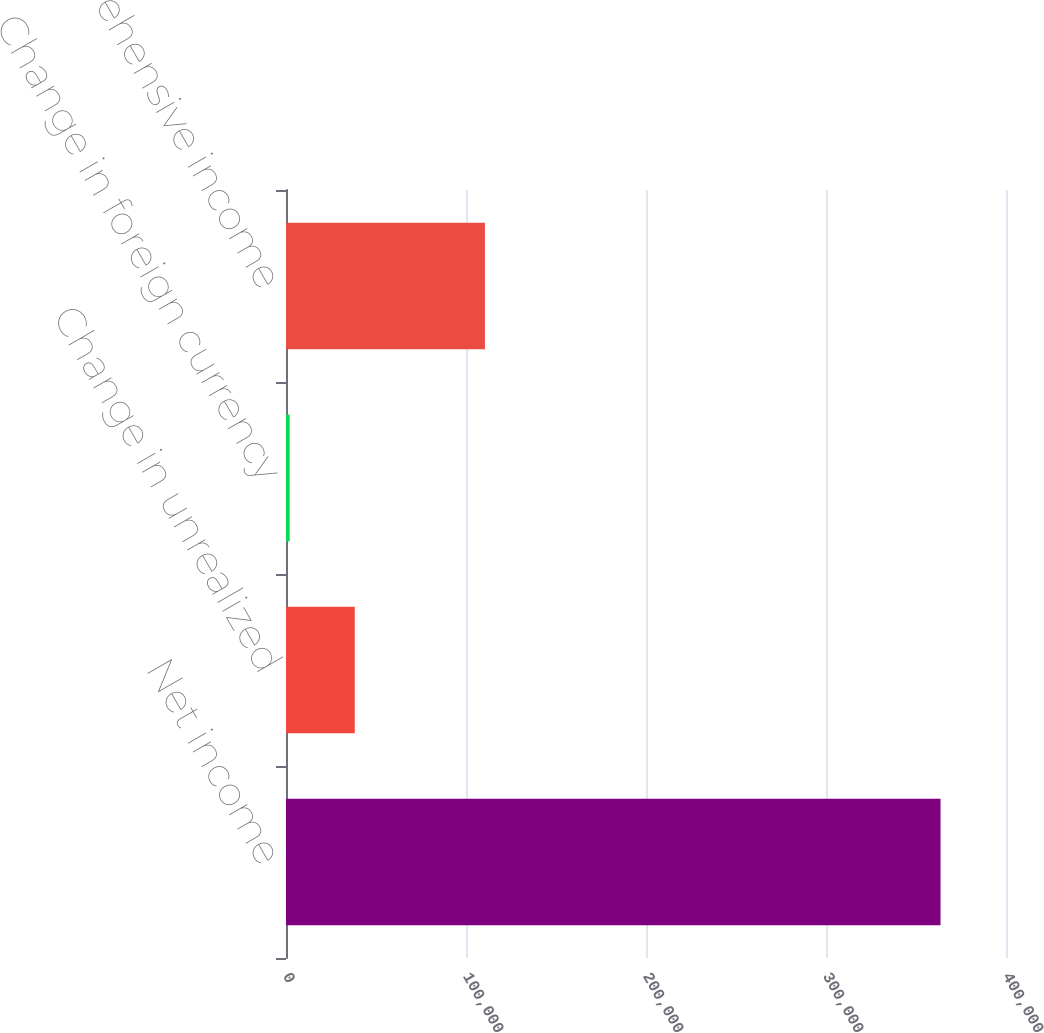<chart> <loc_0><loc_0><loc_500><loc_500><bar_chart><fcel>Net income<fcel>Change in unrealized<fcel>Change in foreign currency<fcel>Other comprehensive income<nl><fcel>363628<fcel>38198.8<fcel>2040<fcel>110516<nl></chart> 